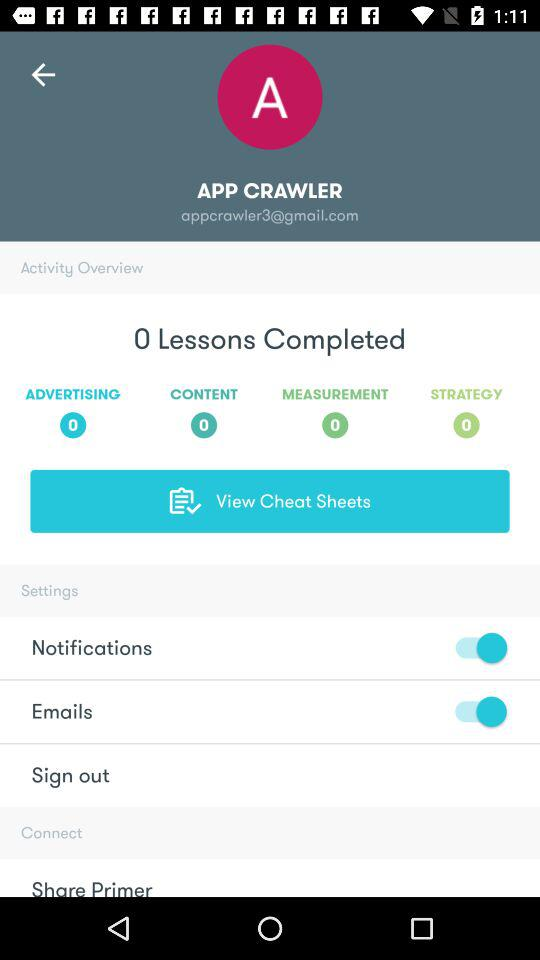What is the status of the notifications? The status is "on". 